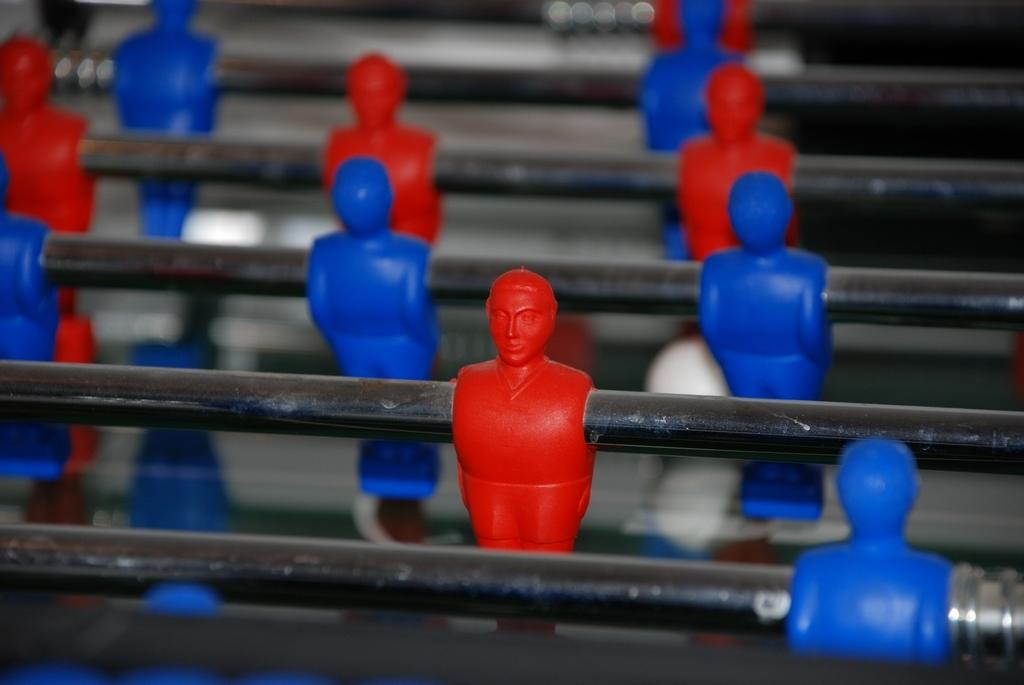What colors are the toys in the image? The toys in the image are red and blue. How are the toys arranged or positioned in the image? The toys are on iron rods. What is the purpose of the crayon in the image? There is no crayon present in the image. 